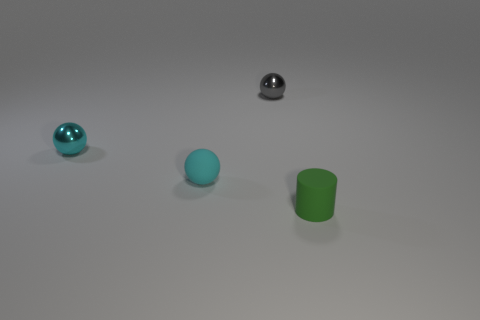How many tiny green matte things have the same shape as the gray shiny object?
Provide a short and direct response. 0. Is the number of small cyan rubber spheres that are on the right side of the tiny cyan shiny ball greater than the number of green rubber cylinders that are in front of the small rubber cylinder?
Offer a very short reply. Yes. There is a tiny metal object that is on the left side of the matte sphere; is it the same color as the matte ball?
Your answer should be compact. Yes. What material is the green cylinder that is the same size as the rubber sphere?
Provide a succinct answer. Rubber. There is a tiny metal object to the right of the cyan metallic ball; what is its color?
Give a very brief answer. Gray. How many rubber spheres are there?
Make the answer very short. 1. Is there a small cyan object that is to the right of the small object in front of the tiny rubber thing that is behind the cylinder?
Offer a very short reply. No. There is a cyan metallic object that is the same size as the green object; what shape is it?
Ensure brevity in your answer.  Sphere. What number of other objects are the same color as the cylinder?
Provide a short and direct response. 0. What material is the small green cylinder?
Offer a very short reply. Rubber. 